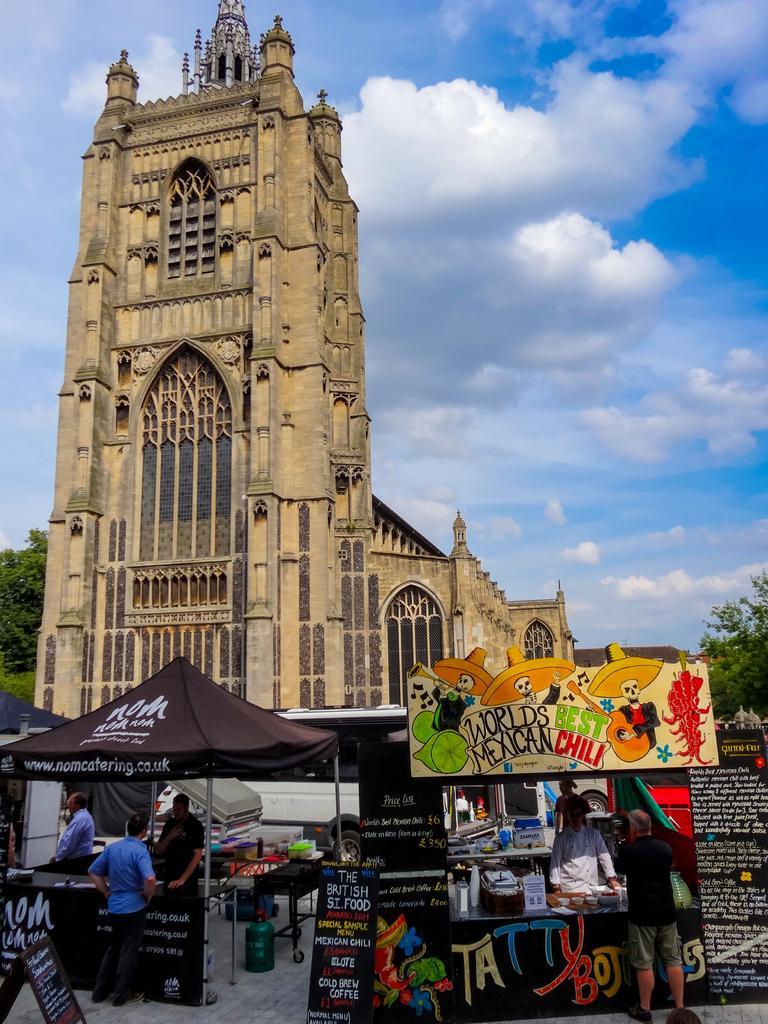How would you summarize this image in a sentence or two? In this picture we can see a building, in front of the building we can find few tents, a vehicle, hoardings and few people, in the background we can see few trees and clouds. 